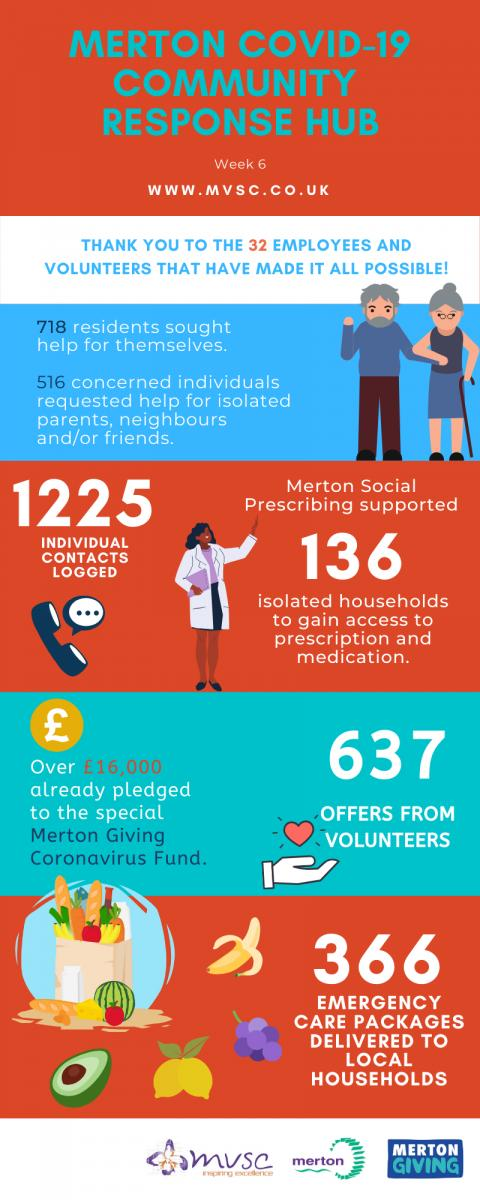Indicate a few pertinent items in this graphic. The account for collecting funds to aid those affected by the COVID-19 pandemic is named the Merton Giving Coronavirus Fund. 